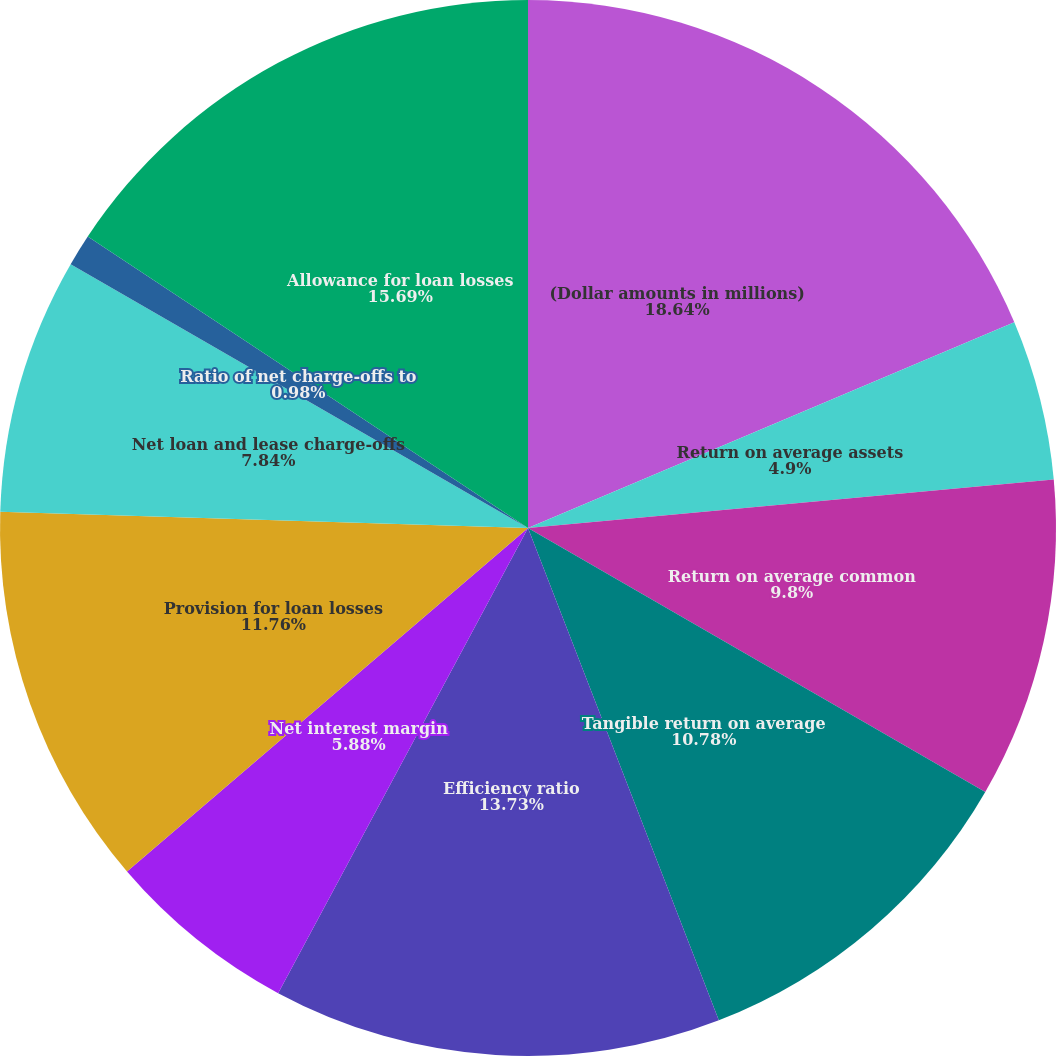Convert chart. <chart><loc_0><loc_0><loc_500><loc_500><pie_chart><fcel>(Dollar amounts in millions)<fcel>Return on average assets<fcel>Return on average common<fcel>Tangible return on average<fcel>Efficiency ratio<fcel>Net interest margin<fcel>Provision for loan losses<fcel>Net loan and lease charge-offs<fcel>Ratio of net charge-offs to<fcel>Allowance for loan losses<nl><fcel>18.63%<fcel>4.9%<fcel>9.8%<fcel>10.78%<fcel>13.73%<fcel>5.88%<fcel>11.76%<fcel>7.84%<fcel>0.98%<fcel>15.69%<nl></chart> 